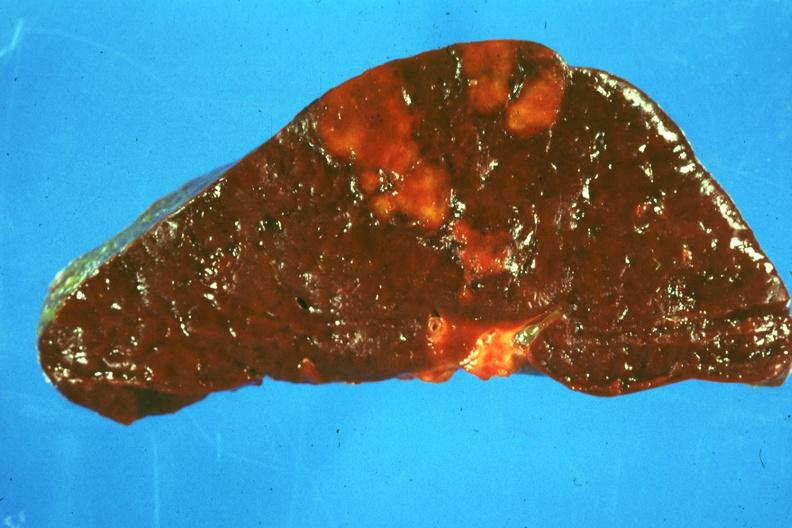s hemorrhage in newborn present?
Answer the question using a single word or phrase. No 